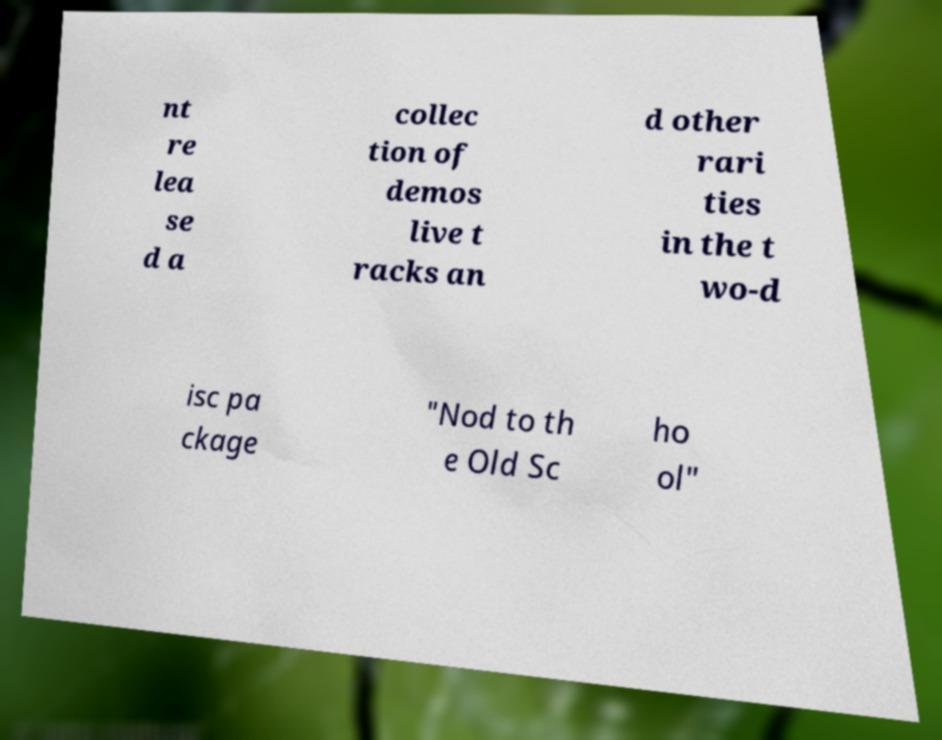Please read and relay the text visible in this image. What does it say? nt re lea se d a collec tion of demos live t racks an d other rari ties in the t wo-d isc pa ckage "Nod to th e Old Sc ho ol" 